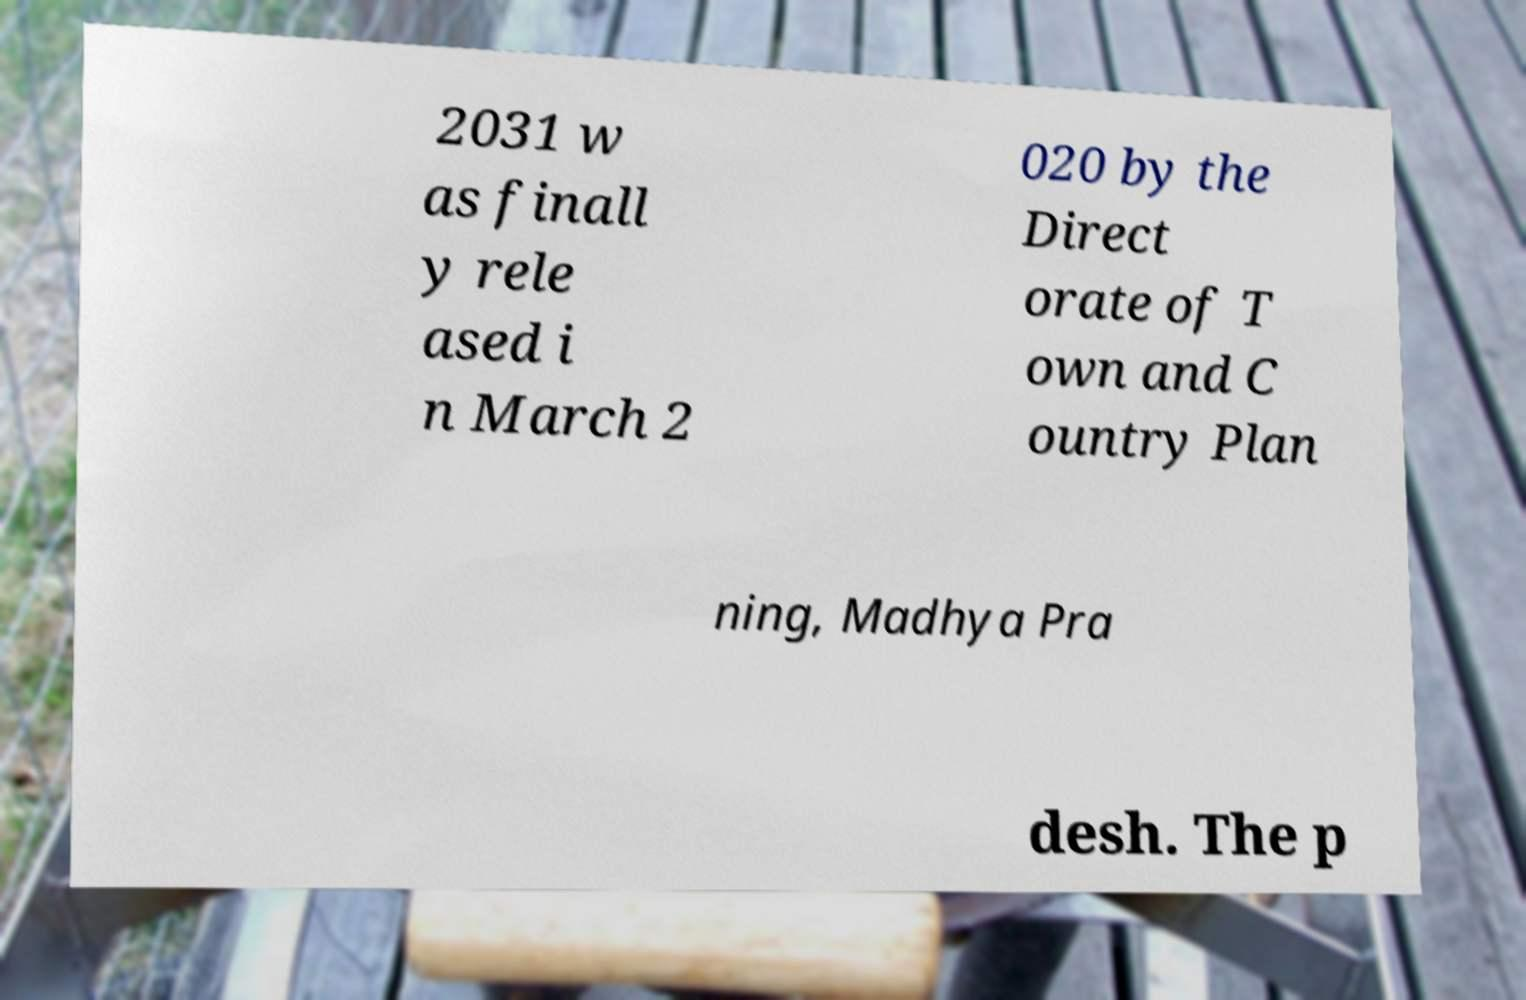For documentation purposes, I need the text within this image transcribed. Could you provide that? 2031 w as finall y rele ased i n March 2 020 by the Direct orate of T own and C ountry Plan ning, Madhya Pra desh. The p 